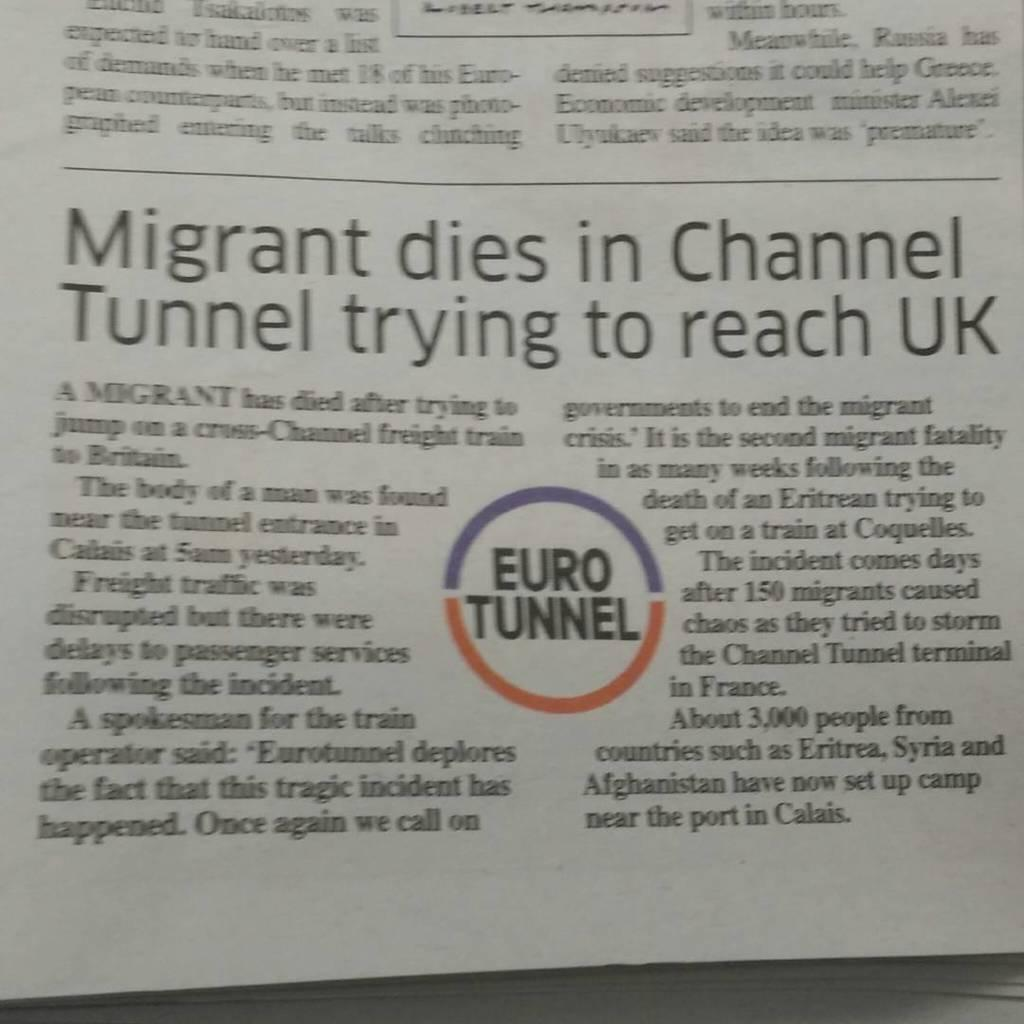<image>
Offer a succinct explanation of the picture presented. A newspaper article describes how a migrant died in UK. 